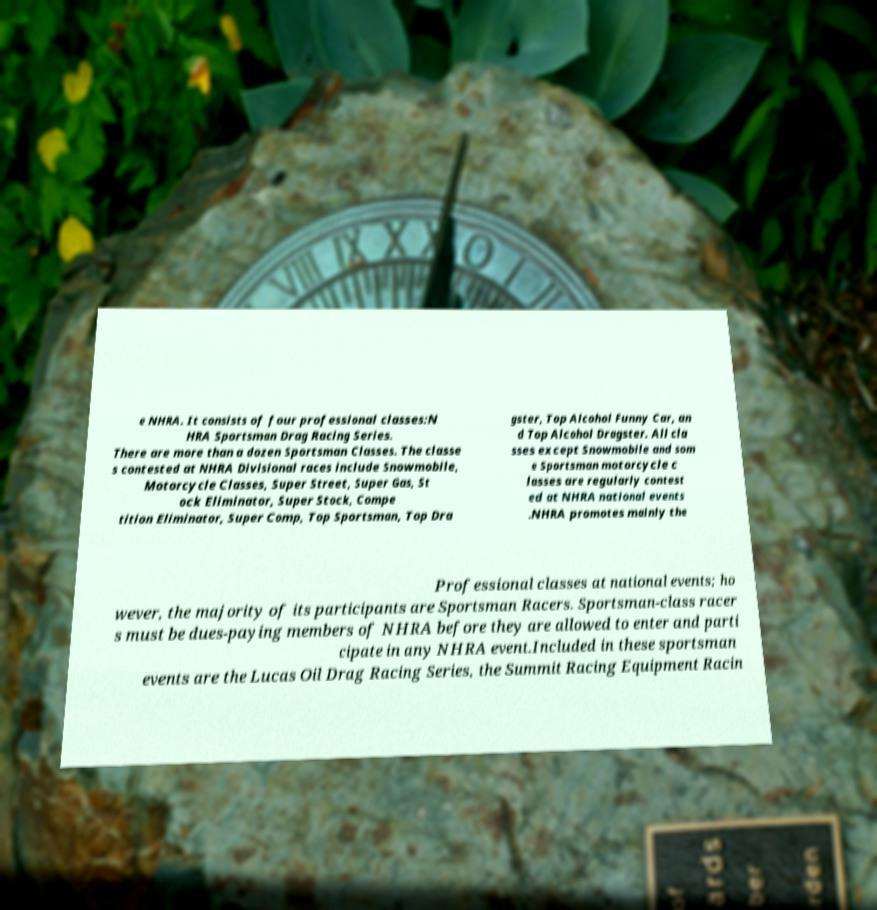Please read and relay the text visible in this image. What does it say? e NHRA. It consists of four professional classes:N HRA Sportsman Drag Racing Series. There are more than a dozen Sportsman Classes. The classe s contested at NHRA Divisional races include Snowmobile, Motorcycle Classes, Super Street, Super Gas, St ock Eliminator, Super Stock, Compe tition Eliminator, Super Comp, Top Sportsman, Top Dra gster, Top Alcohol Funny Car, an d Top Alcohol Dragster. All cla sses except Snowmobile and som e Sportsman motorcycle c lasses are regularly contest ed at NHRA national events .NHRA promotes mainly the Professional classes at national events; ho wever, the majority of its participants are Sportsman Racers. Sportsman-class racer s must be dues-paying members of NHRA before they are allowed to enter and parti cipate in any NHRA event.Included in these sportsman events are the Lucas Oil Drag Racing Series, the Summit Racing Equipment Racin 